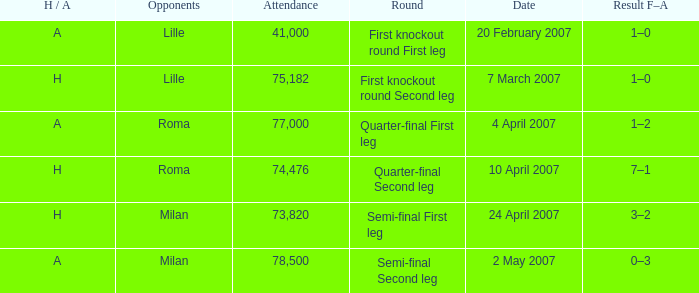Which round happened on 10 april 2007? Quarter-final Second leg. 